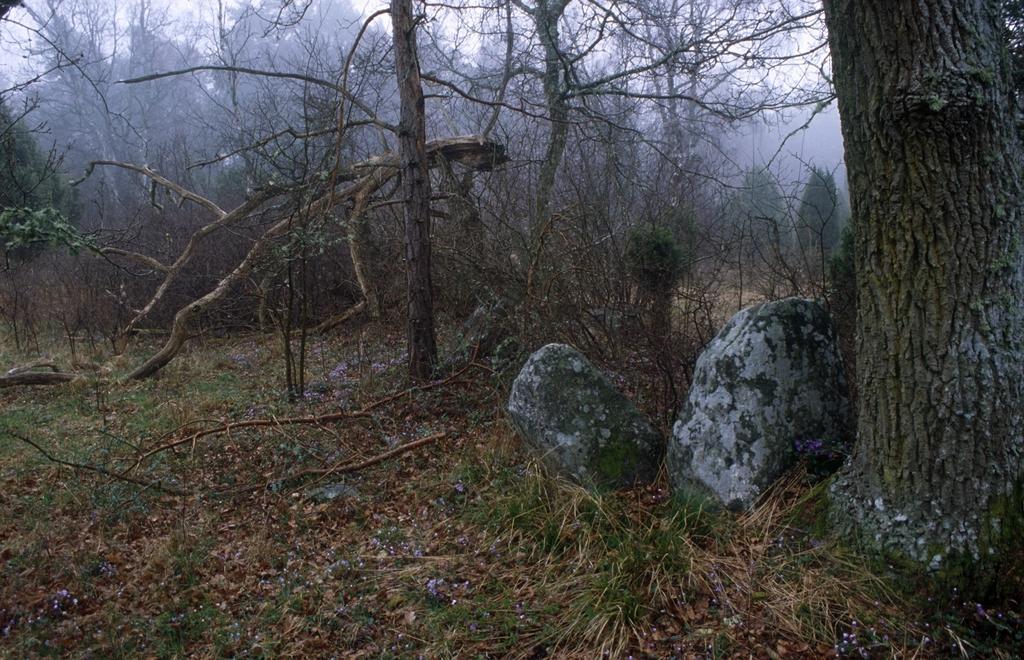Could you give a brief overview of what you see in this image? At the bottom of the picture, we see grass and rocks. There are many trees in the background. This picture might be clicked in the forest. 